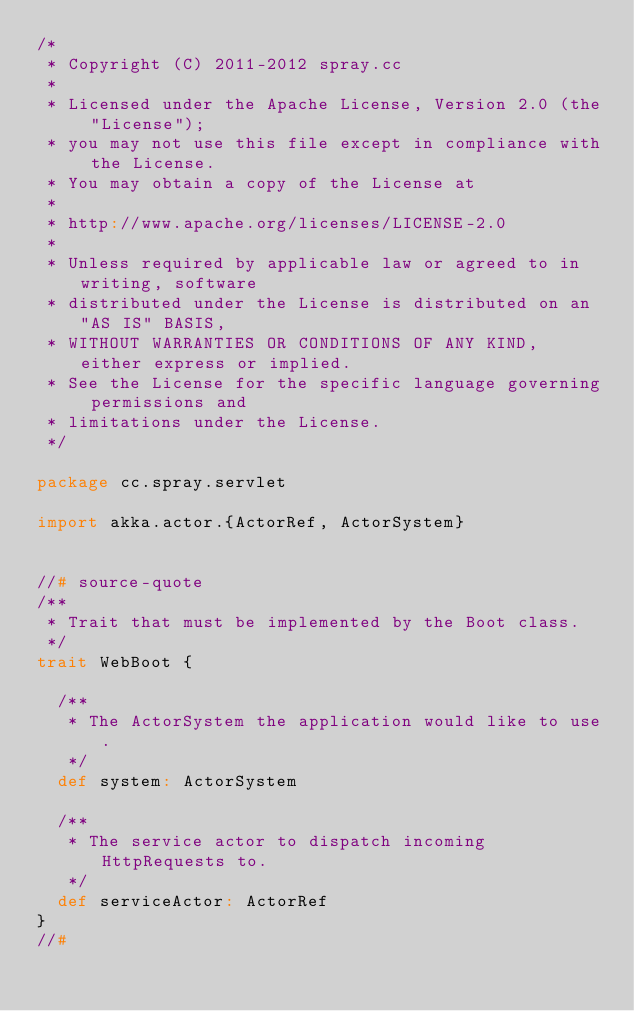Convert code to text. <code><loc_0><loc_0><loc_500><loc_500><_Scala_>/*
 * Copyright (C) 2011-2012 spray.cc
 *
 * Licensed under the Apache License, Version 2.0 (the "License");
 * you may not use this file except in compliance with the License.
 * You may obtain a copy of the License at
 *
 * http://www.apache.org/licenses/LICENSE-2.0
 *
 * Unless required by applicable law or agreed to in writing, software
 * distributed under the License is distributed on an "AS IS" BASIS,
 * WITHOUT WARRANTIES OR CONDITIONS OF ANY KIND, either express or implied.
 * See the License for the specific language governing permissions and
 * limitations under the License.
 */

package cc.spray.servlet

import akka.actor.{ActorRef, ActorSystem}


//# source-quote
/**
 * Trait that must be implemented by the Boot class.
 */
trait WebBoot {

  /**
   * The ActorSystem the application would like to use.
   */
  def system: ActorSystem

  /**
   * The service actor to dispatch incoming HttpRequests to.
   */
  def serviceActor: ActorRef
}
//#</code> 